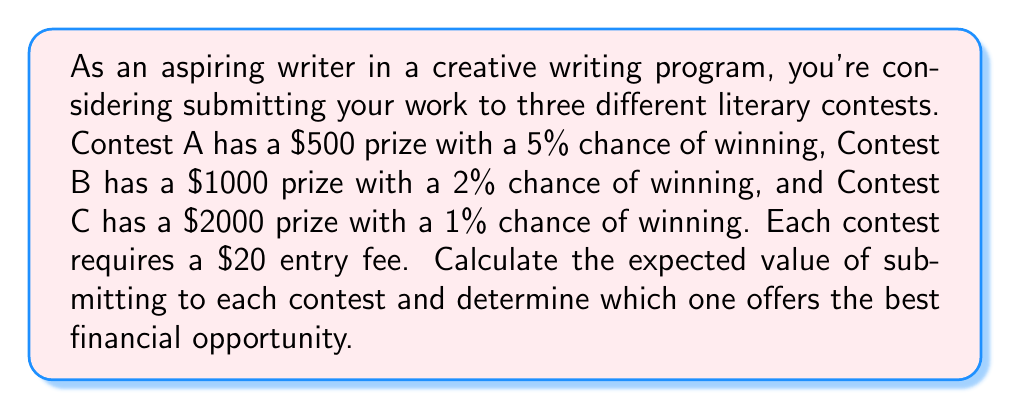Can you solve this math problem? To solve this problem, we need to calculate the expected value for each contest and compare them. The expected value is calculated by multiplying the probability of winning by the prize amount and subtracting the entry fee.

Let's calculate the expected value for each contest:

1. Contest A:
   - Prize: $500
   - Probability of winning: 5% = 0.05
   - Entry fee: $20
   
   Expected Value A = $(500 \times 0.05) - 20$
   $$ EV_A = 25 - 20 = 5 $$

2. Contest B:
   - Prize: $1000
   - Probability of winning: 2% = 0.02
   - Entry fee: $20
   
   Expected Value B = $(1000 \times 0.02) - 20$
   $$ EV_B = 20 - 20 = 0 $$

3. Contest C:
   - Prize: $2000
   - Probability of winning: 1% = 0.01
   - Entry fee: $20
   
   Expected Value C = $(2000 \times 0.01) - 20$
   $$ EV_C = 20 - 20 = 0 $$

Comparing the expected values:
$EV_A = 5$
$EV_B = 0$
$EV_C = 0$

Contest A has the highest expected value of $5, while Contests B and C both have an expected value of $0.
Answer: Contest A offers the best financial opportunity with an expected value of $5. Contests B and C both have an expected value of $0, making them less favorable options. 